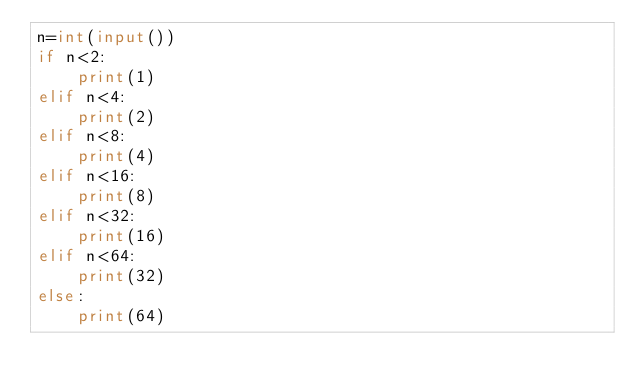<code> <loc_0><loc_0><loc_500><loc_500><_Python_>n=int(input())
if n<2:
    print(1)
elif n<4:
    print(2)
elif n<8:
    print(4)
elif n<16:
    print(8)
elif n<32:
    print(16)
elif n<64:
    print(32)
else:
    print(64)</code> 